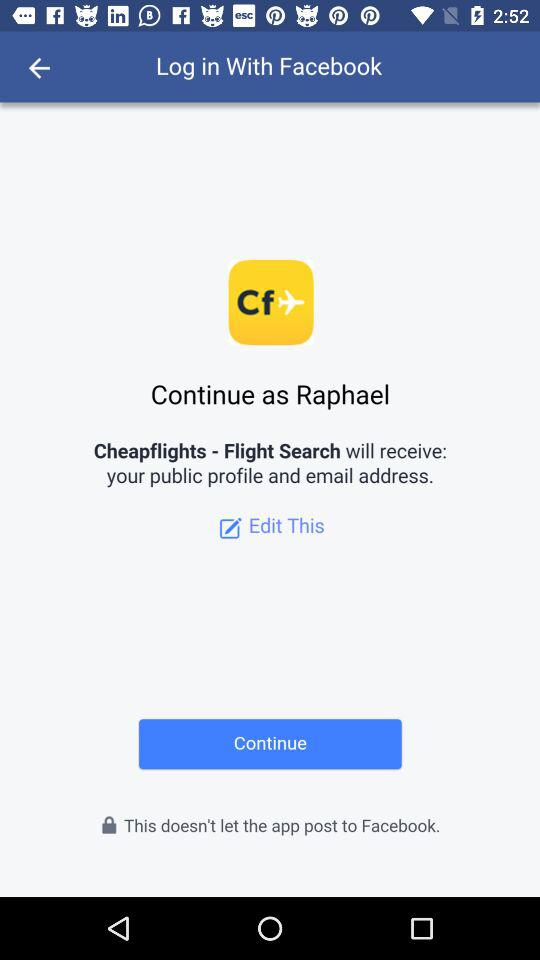What is the user name? The user name is Raphael. 